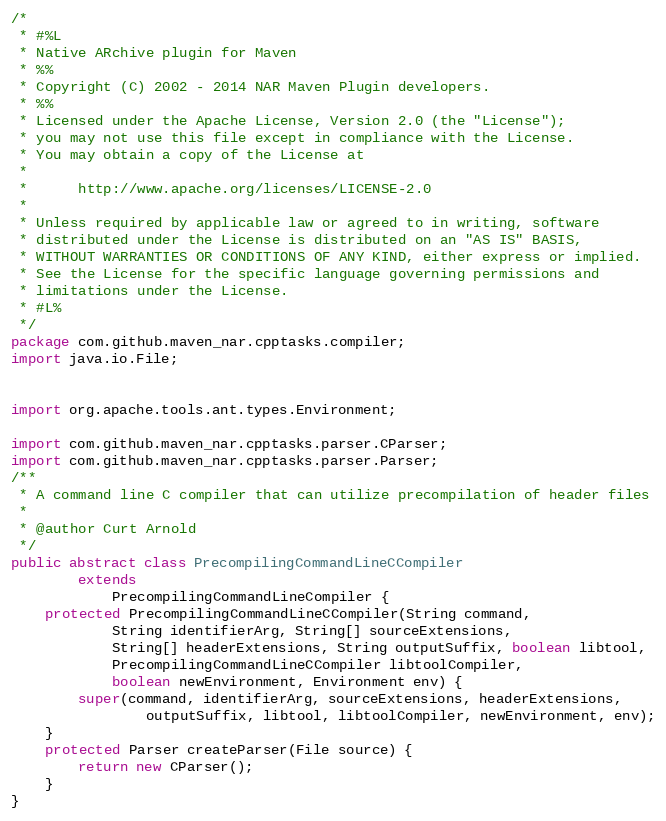Convert code to text. <code><loc_0><loc_0><loc_500><loc_500><_Java_>/*
 * #%L
 * Native ARchive plugin for Maven
 * %%
 * Copyright (C) 2002 - 2014 NAR Maven Plugin developers.
 * %%
 * Licensed under the Apache License, Version 2.0 (the "License");
 * you may not use this file except in compliance with the License.
 * You may obtain a copy of the License at
 * 
 *      http://www.apache.org/licenses/LICENSE-2.0
 * 
 * Unless required by applicable law or agreed to in writing, software
 * distributed under the License is distributed on an "AS IS" BASIS,
 * WITHOUT WARRANTIES OR CONDITIONS OF ANY KIND, either express or implied.
 * See the License for the specific language governing permissions and
 * limitations under the License.
 * #L%
 */
package com.github.maven_nar.cpptasks.compiler;
import java.io.File;


import org.apache.tools.ant.types.Environment;

import com.github.maven_nar.cpptasks.parser.CParser;
import com.github.maven_nar.cpptasks.parser.Parser;
/**
 * A command line C compiler that can utilize precompilation of header files
 * 
 * @author Curt Arnold
 */
public abstract class PrecompilingCommandLineCCompiler
        extends
            PrecompilingCommandLineCompiler {
    protected PrecompilingCommandLineCCompiler(String command,
            String identifierArg, String[] sourceExtensions,
            String[] headerExtensions, String outputSuffix, boolean libtool,
            PrecompilingCommandLineCCompiler libtoolCompiler,
            boolean newEnvironment, Environment env) {
        super(command, identifierArg, sourceExtensions, headerExtensions,
                outputSuffix, libtool, libtoolCompiler, newEnvironment, env);
    }
    protected Parser createParser(File source) {
        return new CParser();
    }
}
</code> 